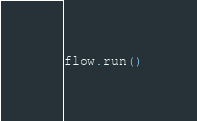<code> <loc_0><loc_0><loc_500><loc_500><_Python_>

flow.run()


</code> 